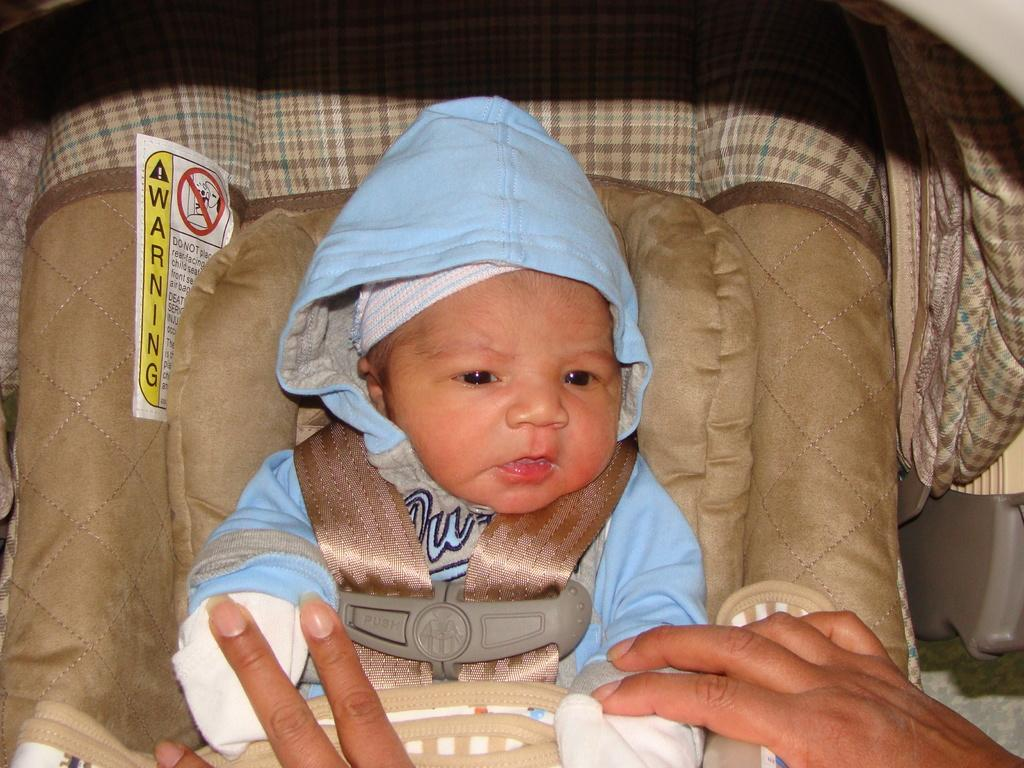What is the main subject in the foreground of the image? There is a baby in a baby seat in the foreground of the image. Can you describe the hands visible at the bottom of the image? The hands of a person are visible at the bottom of the image. What type of car is parked next to the baby seat in the image? There is no car present in the image; it only features a baby in a baby seat and the hands of a person. How many cattle can be seen grazing in the background of the image? There are no cattle present in the image; it only features a baby in a baby seat and the hands of a person. 